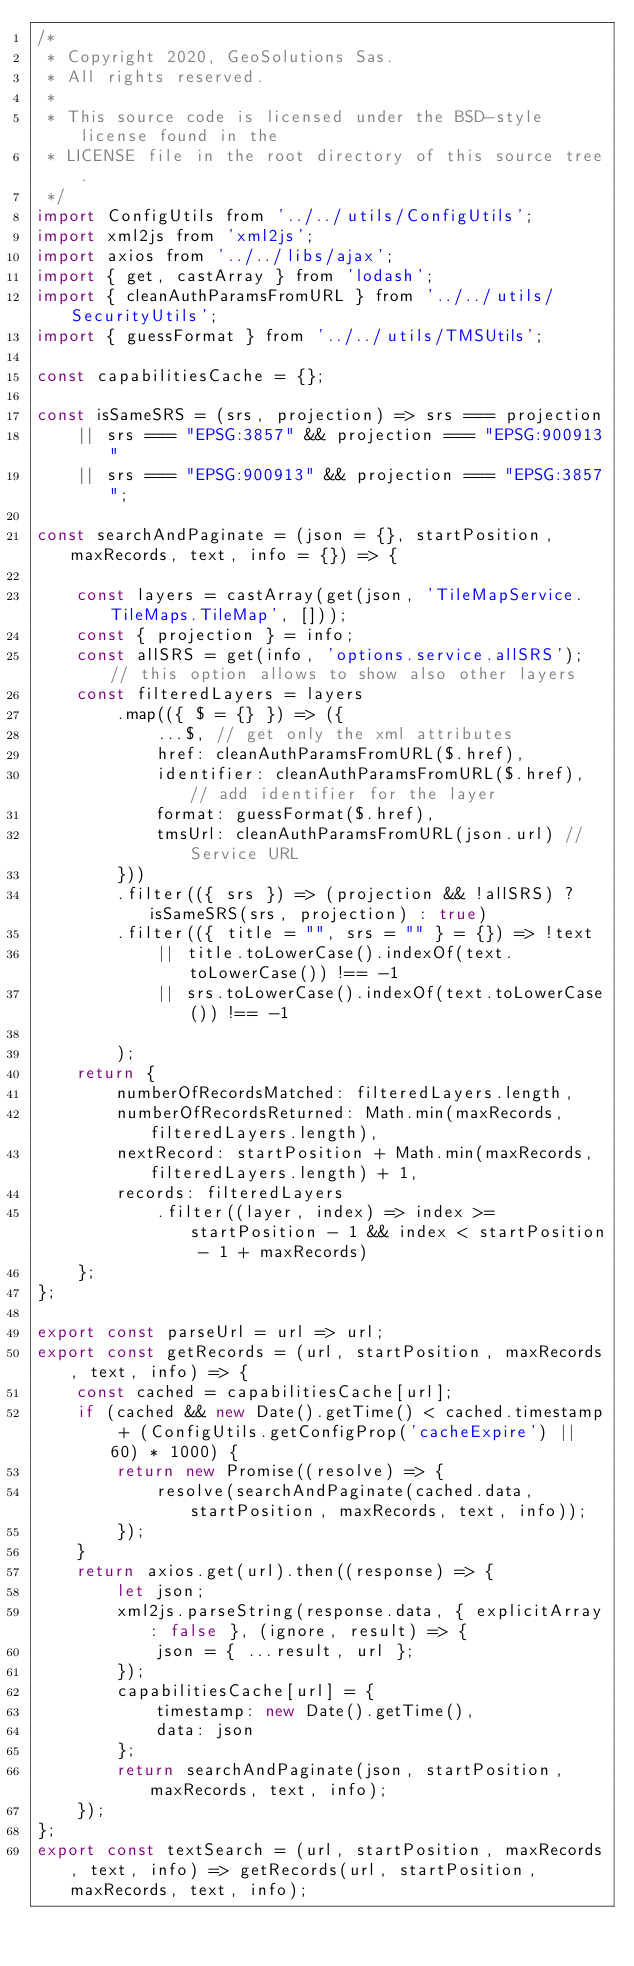<code> <loc_0><loc_0><loc_500><loc_500><_JavaScript_>/*
 * Copyright 2020, GeoSolutions Sas.
 * All rights reserved.
 *
 * This source code is licensed under the BSD-style license found in the
 * LICENSE file in the root directory of this source tree.
 */
import ConfigUtils from '../../utils/ConfigUtils';
import xml2js from 'xml2js';
import axios from '../../libs/ajax';
import { get, castArray } from 'lodash';
import { cleanAuthParamsFromURL } from '../../utils/SecurityUtils';
import { guessFormat } from '../../utils/TMSUtils';

const capabilitiesCache = {};

const isSameSRS = (srs, projection) => srs === projection
    || srs === "EPSG:3857" && projection === "EPSG:900913"
    || srs === "EPSG:900913" && projection === "EPSG:3857";

const searchAndPaginate = (json = {}, startPosition, maxRecords, text, info = {}) => {

    const layers = castArray(get(json, 'TileMapService.TileMaps.TileMap', []));
    const { projection } = info;
    const allSRS = get(info, 'options.service.allSRS'); // this option allows to show also other layers
    const filteredLayers = layers
        .map(({ $ = {} }) => ({
            ...$, // get only the xml attributes
            href: cleanAuthParamsFromURL($.href),
            identifier: cleanAuthParamsFromURL($.href), // add identifier for the layer
            format: guessFormat($.href),
            tmsUrl: cleanAuthParamsFromURL(json.url) // Service URL
        }))
        .filter(({ srs }) => (projection && !allSRS) ? isSameSRS(srs, projection) : true)
        .filter(({ title = "", srs = "" } = {}) => !text
            || title.toLowerCase().indexOf(text.toLowerCase()) !== -1
            || srs.toLowerCase().indexOf(text.toLowerCase()) !== -1

        );
    return {
        numberOfRecordsMatched: filteredLayers.length,
        numberOfRecordsReturned: Math.min(maxRecords, filteredLayers.length),
        nextRecord: startPosition + Math.min(maxRecords, filteredLayers.length) + 1,
        records: filteredLayers
            .filter((layer, index) => index >= startPosition - 1 && index < startPosition - 1 + maxRecords)
    };
};

export const parseUrl = url => url;
export const getRecords = (url, startPosition, maxRecords, text, info) => {
    const cached = capabilitiesCache[url];
    if (cached && new Date().getTime() < cached.timestamp + (ConfigUtils.getConfigProp('cacheExpire') || 60) * 1000) {
        return new Promise((resolve) => {
            resolve(searchAndPaginate(cached.data, startPosition, maxRecords, text, info));
        });
    }
    return axios.get(url).then((response) => {
        let json;
        xml2js.parseString(response.data, { explicitArray: false }, (ignore, result) => {
            json = { ...result, url };
        });
        capabilitiesCache[url] = {
            timestamp: new Date().getTime(),
            data: json
        };
        return searchAndPaginate(json, startPosition, maxRecords, text, info);
    });
};
export const textSearch = (url, startPosition, maxRecords, text, info) => getRecords(url, startPosition, maxRecords, text, info);

</code> 